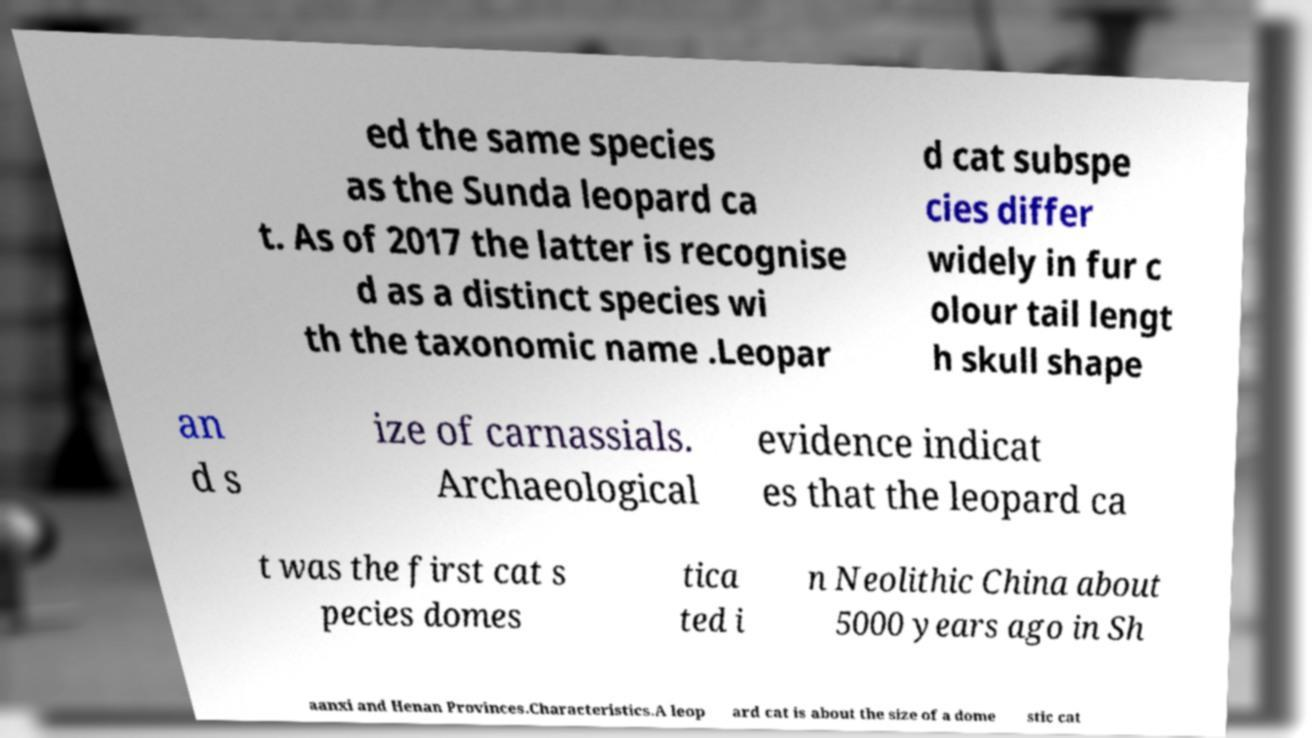I need the written content from this picture converted into text. Can you do that? ed the same species as the Sunda leopard ca t. As of 2017 the latter is recognise d as a distinct species wi th the taxonomic name .Leopar d cat subspe cies differ widely in fur c olour tail lengt h skull shape an d s ize of carnassials. Archaeological evidence indicat es that the leopard ca t was the first cat s pecies domes tica ted i n Neolithic China about 5000 years ago in Sh aanxi and Henan Provinces.Characteristics.A leop ard cat is about the size of a dome stic cat 